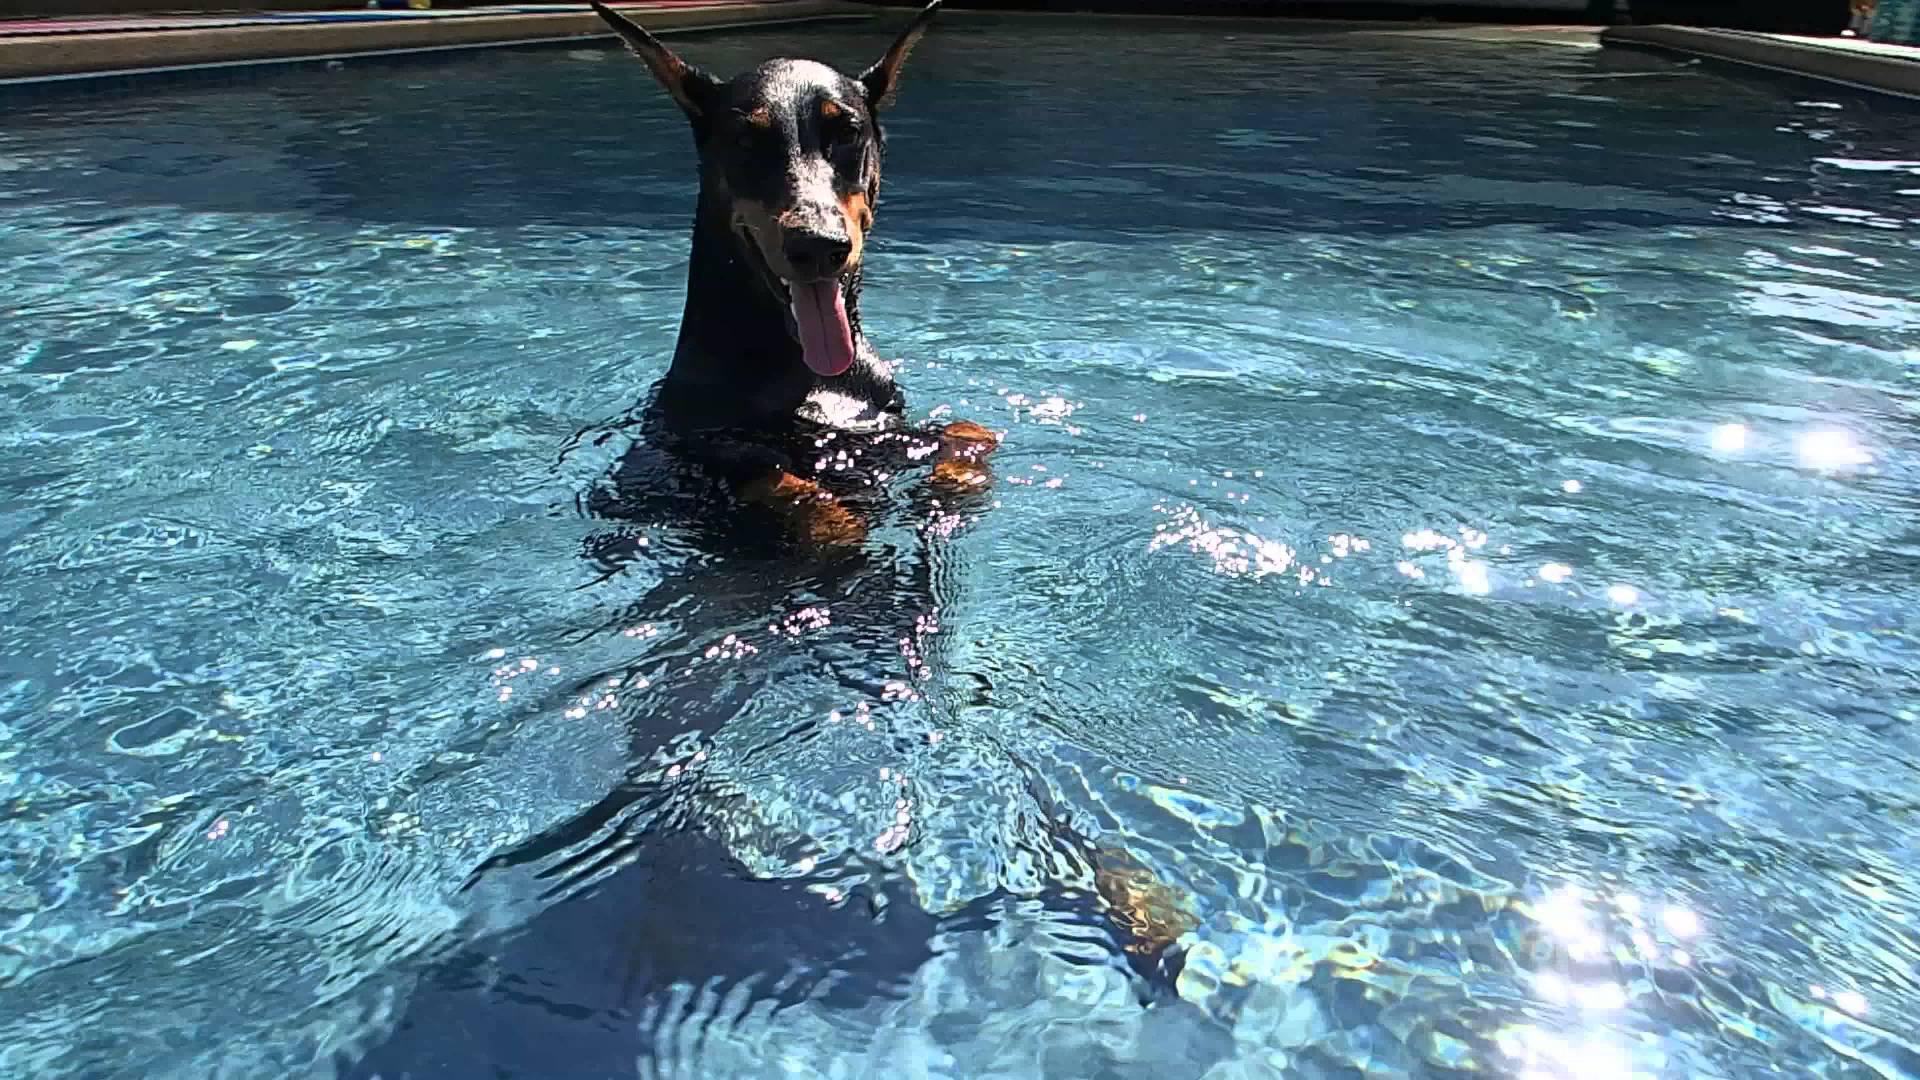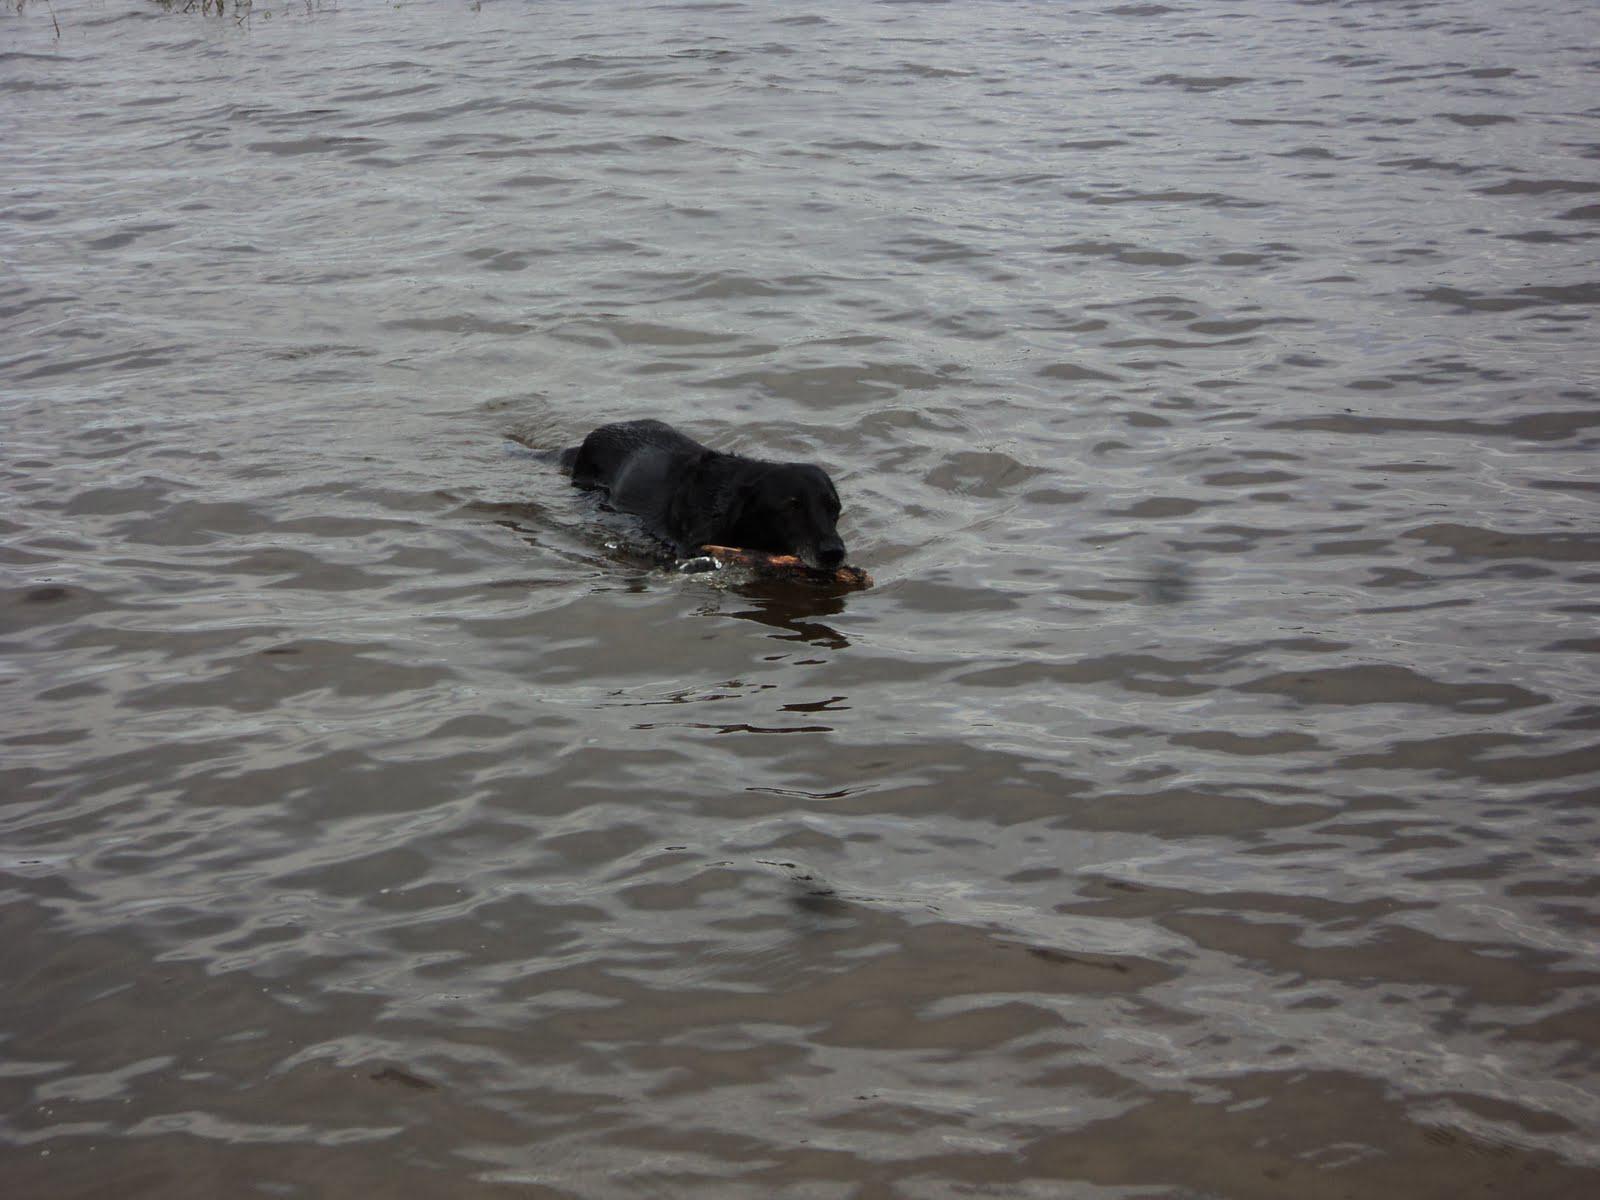The first image is the image on the left, the second image is the image on the right. Examine the images to the left and right. Is the description "There are three animals in the water." accurate? Answer yes or no. No. The first image is the image on the left, the second image is the image on the right. For the images shown, is this caption "The dog in each image is alone in the water." true? Answer yes or no. Yes. 